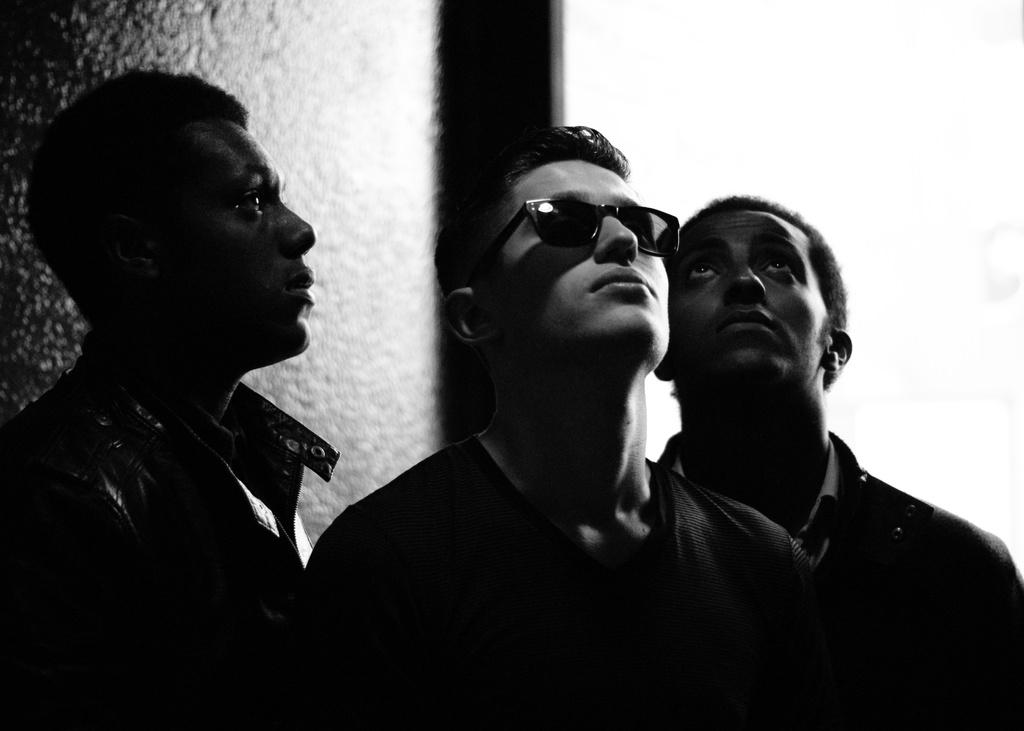How many people are in the image? There are three persons in the center of the image. What is the middle person wearing? The middle person is wearing goggles. What can be seen in the background of the image? There is a wall in the background of the image. What type of clover is growing on the wall in the image? There is no clover visible in the image; it only shows three persons and a wall in the background. 